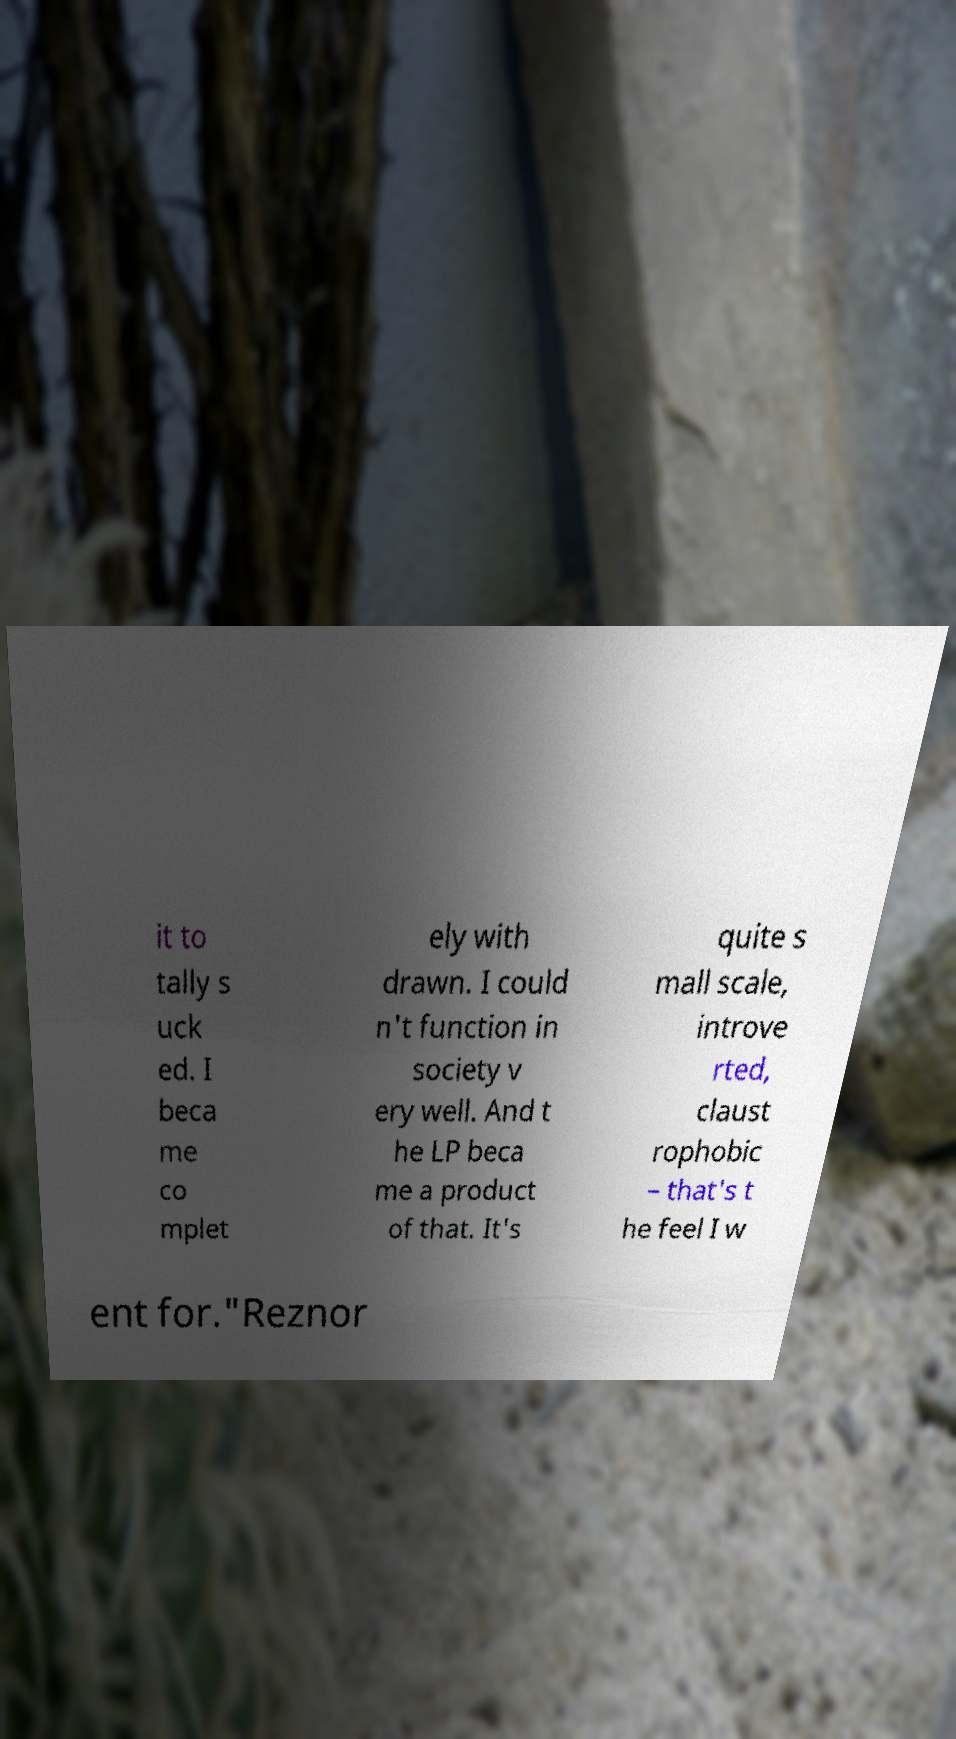Please read and relay the text visible in this image. What does it say? it to tally s uck ed. I beca me co mplet ely with drawn. I could n't function in society v ery well. And t he LP beca me a product of that. It's quite s mall scale, introve rted, claust rophobic – that's t he feel I w ent for."Reznor 